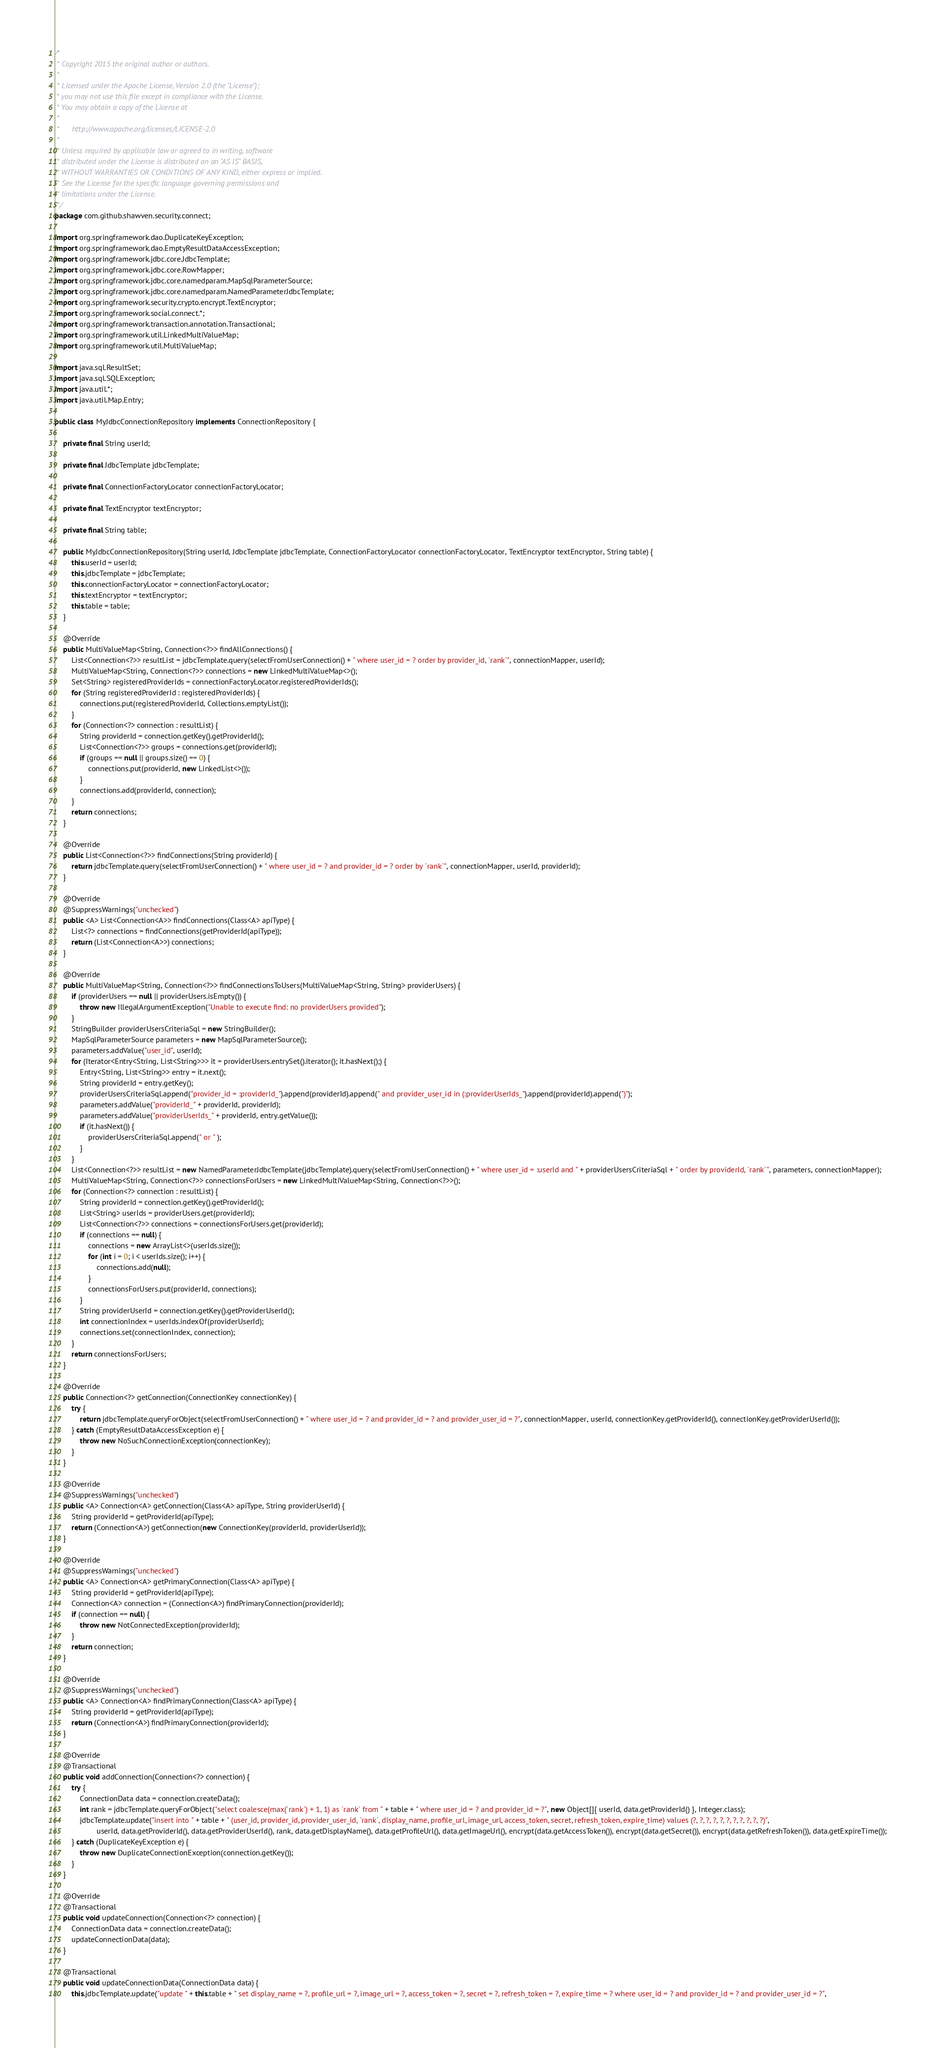<code> <loc_0><loc_0><loc_500><loc_500><_Java_>/*
 * Copyright 2015 the original author or authors.
 *
 * Licensed under the Apache License, Version 2.0 (the "License");
 * you may not use this file except in compliance with the License.
 * You may obtain a copy of the License at
 *
 *      http://www.apache.org/licenses/LICENSE-2.0
 *
 * Unless required by applicable law or agreed to in writing, software
 * distributed under the License is distributed on an "AS IS" BASIS,
 * WITHOUT WARRANTIES OR CONDITIONS OF ANY KIND, either express or implied.
 * See the License for the specific language governing permissions and
 * limitations under the License.
 */
package com.github.shawven.security.connect;

import org.springframework.dao.DuplicateKeyException;
import org.springframework.dao.EmptyResultDataAccessException;
import org.springframework.jdbc.core.JdbcTemplate;
import org.springframework.jdbc.core.RowMapper;
import org.springframework.jdbc.core.namedparam.MapSqlParameterSource;
import org.springframework.jdbc.core.namedparam.NamedParameterJdbcTemplate;
import org.springframework.security.crypto.encrypt.TextEncryptor;
import org.springframework.social.connect.*;
import org.springframework.transaction.annotation.Transactional;
import org.springframework.util.LinkedMultiValueMap;
import org.springframework.util.MultiValueMap;

import java.sql.ResultSet;
import java.sql.SQLException;
import java.util.*;
import java.util.Map.Entry;

public class MyJdbcConnectionRepository implements ConnectionRepository {

    private final String userId;

    private final JdbcTemplate jdbcTemplate;

    private final ConnectionFactoryLocator connectionFactoryLocator;

    private final TextEncryptor textEncryptor;

    private final String table;

    public MyJdbcConnectionRepository(String userId, JdbcTemplate jdbcTemplate, ConnectionFactoryLocator connectionFactoryLocator, TextEncryptor textEncryptor, String table) {
        this.userId = userId;
        this.jdbcTemplate = jdbcTemplate;
        this.connectionFactoryLocator = connectionFactoryLocator;
        this.textEncryptor = textEncryptor;
        this.table = table;
    }

    @Override
    public MultiValueMap<String, Connection<?>> findAllConnections() {
        List<Connection<?>> resultList = jdbcTemplate.query(selectFromUserConnection() + " where user_id = ? order by provider_id, `rank`", connectionMapper, userId);
        MultiValueMap<String, Connection<?>> connections = new LinkedMultiValueMap<>();
        Set<String> registeredProviderIds = connectionFactoryLocator.registeredProviderIds();
        for (String registeredProviderId : registeredProviderIds) {
            connections.put(registeredProviderId, Collections.emptyList());
        }
        for (Connection<?> connection : resultList) {
            String providerId = connection.getKey().getProviderId();
            List<Connection<?>> groups = connections.get(providerId);
            if (groups == null || groups.size() == 0) {
                connections.put(providerId, new LinkedList<>());
            }
            connections.add(providerId, connection);
        }
        return connections;
    }

    @Override
    public List<Connection<?>> findConnections(String providerId) {
        return jdbcTemplate.query(selectFromUserConnection() + " where user_id = ? and provider_id = ? order by `rank`", connectionMapper, userId, providerId);
    }

    @Override
    @SuppressWarnings("unchecked")
    public <A> List<Connection<A>> findConnections(Class<A> apiType) {
        List<?> connections = findConnections(getProviderId(apiType));
        return (List<Connection<A>>) connections;
    }

    @Override
    public MultiValueMap<String, Connection<?>> findConnectionsToUsers(MultiValueMap<String, String> providerUsers) {
        if (providerUsers == null || providerUsers.isEmpty()) {
            throw new IllegalArgumentException("Unable to execute find: no providerUsers provided");
        }
        StringBuilder providerUsersCriteriaSql = new StringBuilder();
        MapSqlParameterSource parameters = new MapSqlParameterSource();
        parameters.addValue("user_id", userId);
        for (Iterator<Entry<String, List<String>>> it = providerUsers.entrySet().iterator(); it.hasNext();) {
            Entry<String, List<String>> entry = it.next();
            String providerId = entry.getKey();
            providerUsersCriteriaSql.append("provider_id = :providerId_").append(providerId).append(" and provider_user_id in (:providerUserIds_").append(providerId).append(")");
            parameters.addValue("providerId_" + providerId, providerId);
            parameters.addValue("providerUserIds_" + providerId, entry.getValue());
            if (it.hasNext()) {
                providerUsersCriteriaSql.append(" or " );
            }
        }
        List<Connection<?>> resultList = new NamedParameterJdbcTemplate(jdbcTemplate).query(selectFromUserConnection() + " where user_id = :userId and " + providerUsersCriteriaSql + " order by providerId, `rank`", parameters, connectionMapper);
        MultiValueMap<String, Connection<?>> connectionsForUsers = new LinkedMultiValueMap<String, Connection<?>>();
        for (Connection<?> connection : resultList) {
            String providerId = connection.getKey().getProviderId();
            List<String> userIds = providerUsers.get(providerId);
            List<Connection<?>> connections = connectionsForUsers.get(providerId);
            if (connections == null) {
                connections = new ArrayList<>(userIds.size());
                for (int i = 0; i < userIds.size(); i++) {
                    connections.add(null);
                }
                connectionsForUsers.put(providerId, connections);
            }
            String providerUserId = connection.getKey().getProviderUserId();
            int connectionIndex = userIds.indexOf(providerUserId);
            connections.set(connectionIndex, connection);
        }
        return connectionsForUsers;
    }

    @Override
    public Connection<?> getConnection(ConnectionKey connectionKey) {
        try {
            return jdbcTemplate.queryForObject(selectFromUserConnection() + " where user_id = ? and provider_id = ? and provider_user_id = ?", connectionMapper, userId, connectionKey.getProviderId(), connectionKey.getProviderUserId());
        } catch (EmptyResultDataAccessException e) {
            throw new NoSuchConnectionException(connectionKey);
        }
    }

    @Override
    @SuppressWarnings("unchecked")
    public <A> Connection<A> getConnection(Class<A> apiType, String providerUserId) {
        String providerId = getProviderId(apiType);
        return (Connection<A>) getConnection(new ConnectionKey(providerId, providerUserId));
    }

    @Override
    @SuppressWarnings("unchecked")
    public <A> Connection<A> getPrimaryConnection(Class<A> apiType) {
        String providerId = getProviderId(apiType);
        Connection<A> connection = (Connection<A>) findPrimaryConnection(providerId);
        if (connection == null) {
            throw new NotConnectedException(providerId);
        }
        return connection;
    }

    @Override
    @SuppressWarnings("unchecked")
    public <A> Connection<A> findPrimaryConnection(Class<A> apiType) {
        String providerId = getProviderId(apiType);
        return (Connection<A>) findPrimaryConnection(providerId);
    }

    @Override
    @Transactional
    public void addConnection(Connection<?> connection) {
        try {
            ConnectionData data = connection.createData();
            int rank = jdbcTemplate.queryForObject("select coalesce(max(`rank`) + 1, 1) as `rank` from " + table + " where user_id = ? and provider_id = ?", new Object[]{ userId, data.getProviderId() }, Integer.class);
            jdbcTemplate.update("insert into " + table + " (user_id, provider_id, provider_user_id, `rank`, display_name, profile_url, image_url, access_token, secret, refresh_token, expire_time) values (?, ?, ?, ?, ?, ?, ?, ?, ?, ?, ?)",
                    userId, data.getProviderId(), data.getProviderUserId(), rank, data.getDisplayName(), data.getProfileUrl(), data.getImageUrl(), encrypt(data.getAccessToken()), encrypt(data.getSecret()), encrypt(data.getRefreshToken()), data.getExpireTime());
        } catch (DuplicateKeyException e) {
            throw new DuplicateConnectionException(connection.getKey());
        }
    }

    @Override
    @Transactional
    public void updateConnection(Connection<?> connection) {
        ConnectionData data = connection.createData();
        updateConnectionData(data);
    }

    @Transactional
    public void updateConnectionData(ConnectionData data) {
        this.jdbcTemplate.update("update " + this.table + " set display_name = ?, profile_url = ?, image_url = ?, access_token = ?, secret = ?, refresh_token = ?, expire_time = ? where user_id = ? and provider_id = ? and provider_user_id = ?",</code> 